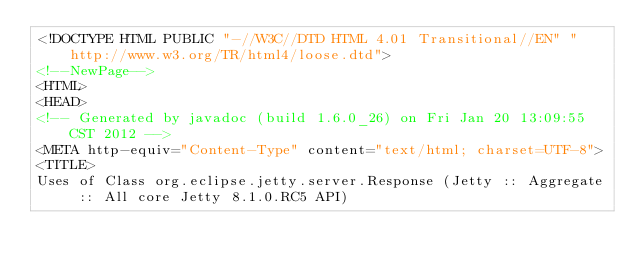<code> <loc_0><loc_0><loc_500><loc_500><_HTML_><!DOCTYPE HTML PUBLIC "-//W3C//DTD HTML 4.01 Transitional//EN" "http://www.w3.org/TR/html4/loose.dtd">
<!--NewPage-->
<HTML>
<HEAD>
<!-- Generated by javadoc (build 1.6.0_26) on Fri Jan 20 13:09:55 CST 2012 -->
<META http-equiv="Content-Type" content="text/html; charset=UTF-8">
<TITLE>
Uses of Class org.eclipse.jetty.server.Response (Jetty :: Aggregate :: All core Jetty 8.1.0.RC5 API)</code> 